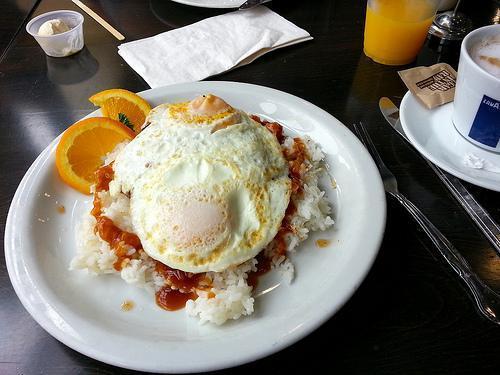How many pieces of silverware are there?
Give a very brief answer. 2. 